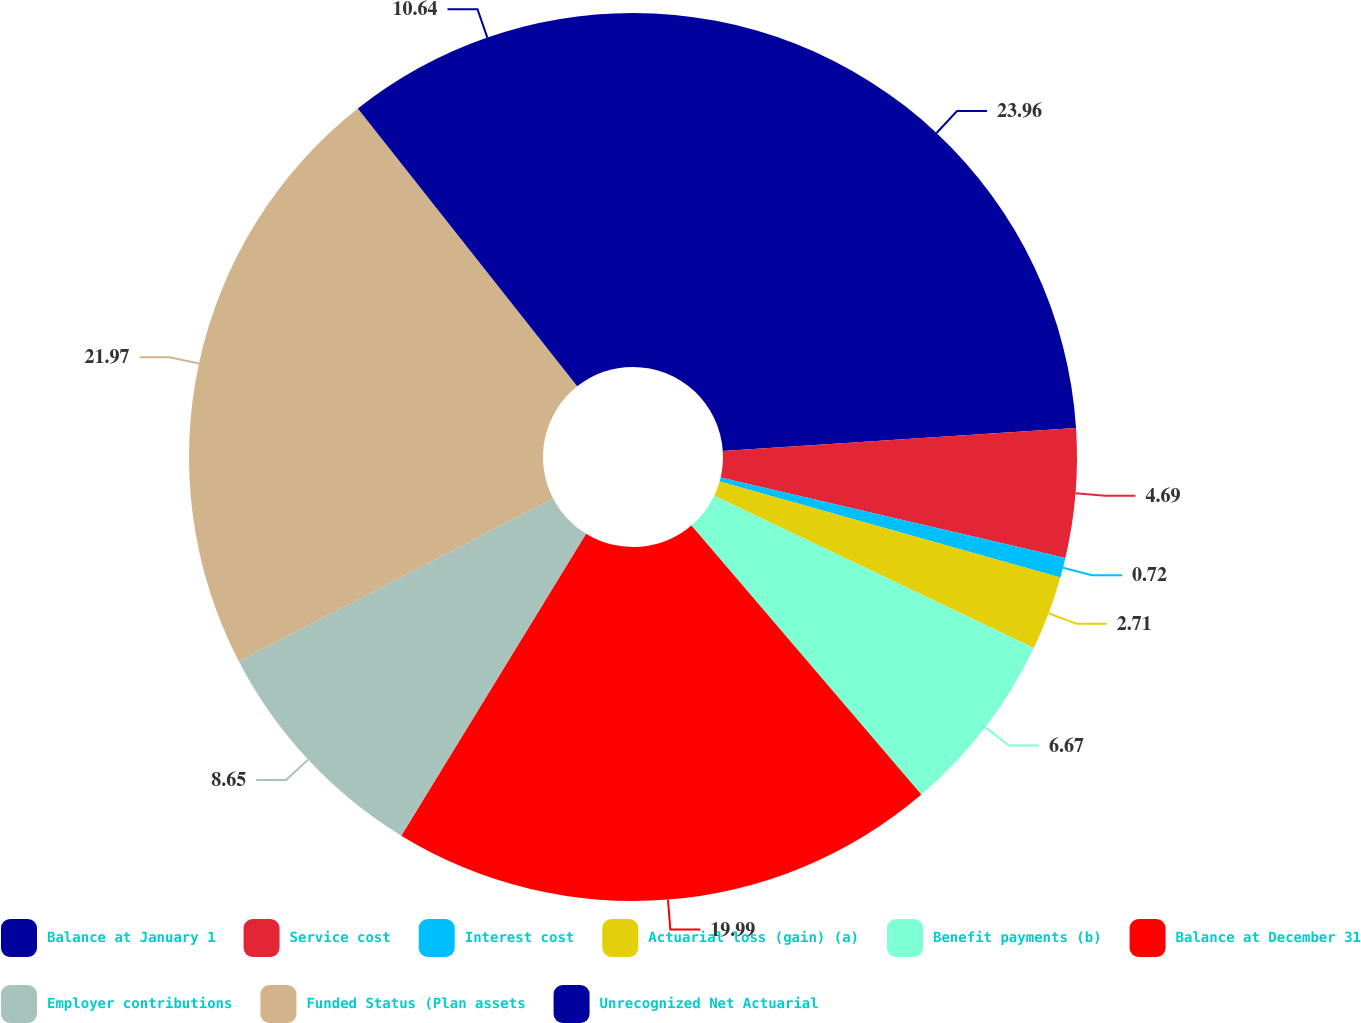Convert chart. <chart><loc_0><loc_0><loc_500><loc_500><pie_chart><fcel>Balance at January 1<fcel>Service cost<fcel>Interest cost<fcel>Actuarial loss (gain) (a)<fcel>Benefit payments (b)<fcel>Balance at December 31<fcel>Employer contributions<fcel>Funded Status (Plan assets<fcel>Unrecognized Net Actuarial<nl><fcel>23.96%<fcel>4.69%<fcel>0.72%<fcel>2.71%<fcel>6.67%<fcel>19.99%<fcel>8.65%<fcel>21.97%<fcel>10.64%<nl></chart> 